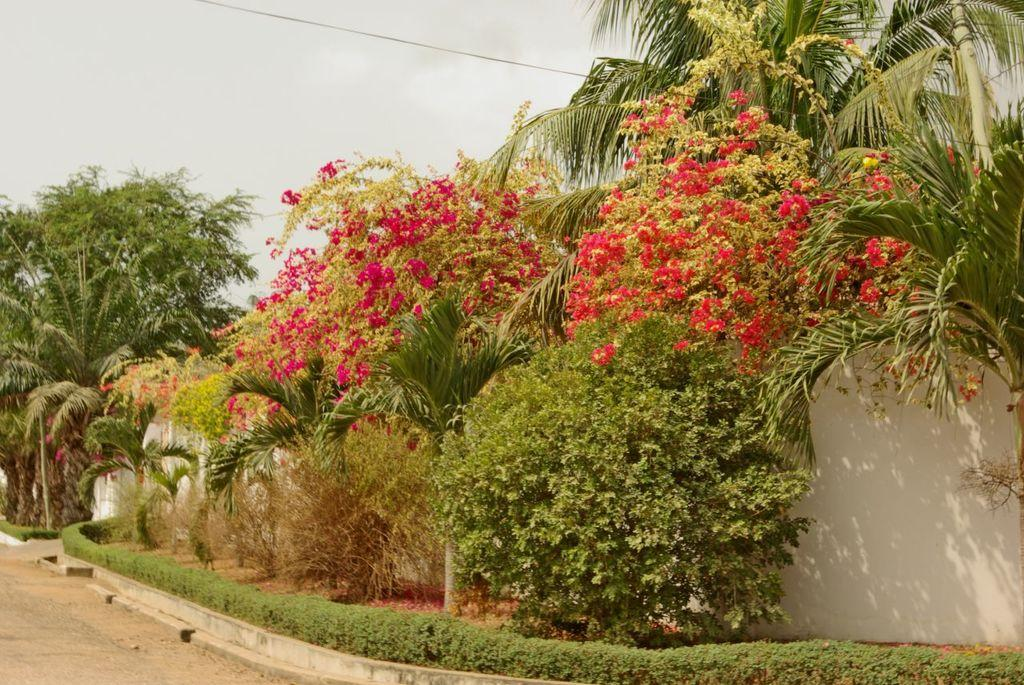What type of vegetation is present in the image? There are flower plants and trees in the image. What can be seen surrounding the vegetation in the image? There is a boundary wall in the image. How many houses can be seen in the image? There are no houses present in the image; it features flower plants, trees, and a boundary wall. What type of twig is visible in the image? There is no twig visible in the image. 